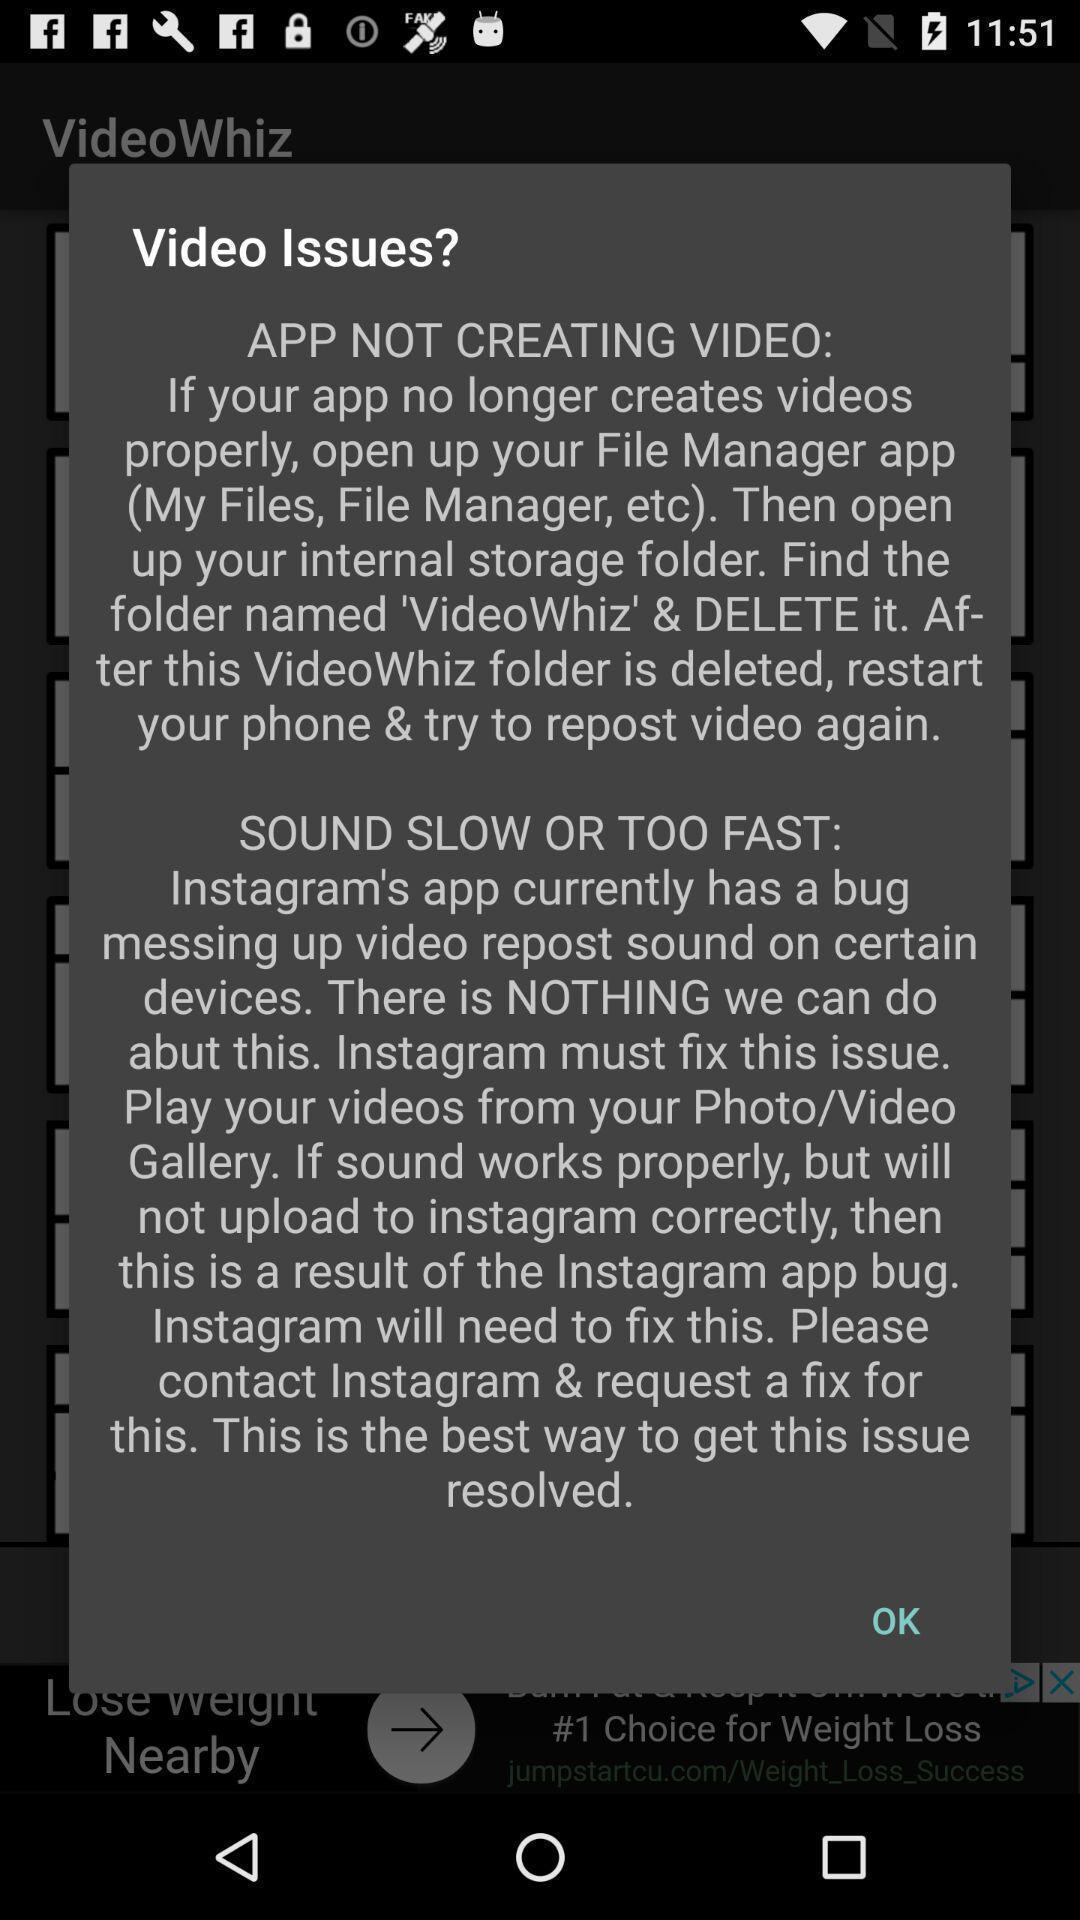What can you discern from this picture? Pop-up displaying the video issue. 